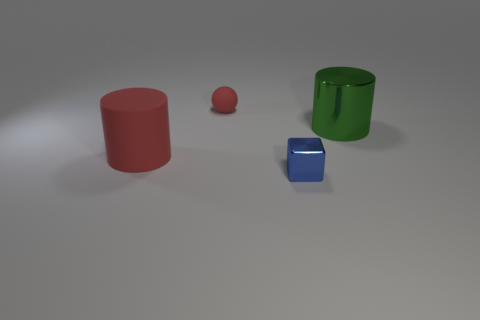What number of shiny blocks have the same size as the red matte cylinder?
Offer a terse response. 0. There is a sphere that is the same color as the large rubber thing; what is its size?
Provide a succinct answer. Small. How big is the object that is both left of the metallic block and behind the big red matte cylinder?
Your response must be concise. Small. What number of red rubber cylinders are in front of the rubber thing to the left of the red object that is behind the metal cylinder?
Make the answer very short. 0. Are there any big things that have the same color as the tiny ball?
Your answer should be very brief. Yes. There is a thing that is the same size as the metal cylinder; what color is it?
Your answer should be compact. Red. What is the shape of the matte thing left of the red rubber thing that is behind the big cylinder to the right of the red rubber ball?
Provide a short and direct response. Cylinder. There is a object that is to the right of the small blue object; what number of things are to the left of it?
Keep it short and to the point. 3. There is a matte object that is in front of the large green shiny cylinder; does it have the same shape as the large thing that is on the right side of the sphere?
Your answer should be compact. Yes. There is a large red cylinder; what number of big cylinders are to the right of it?
Provide a succinct answer. 1. 